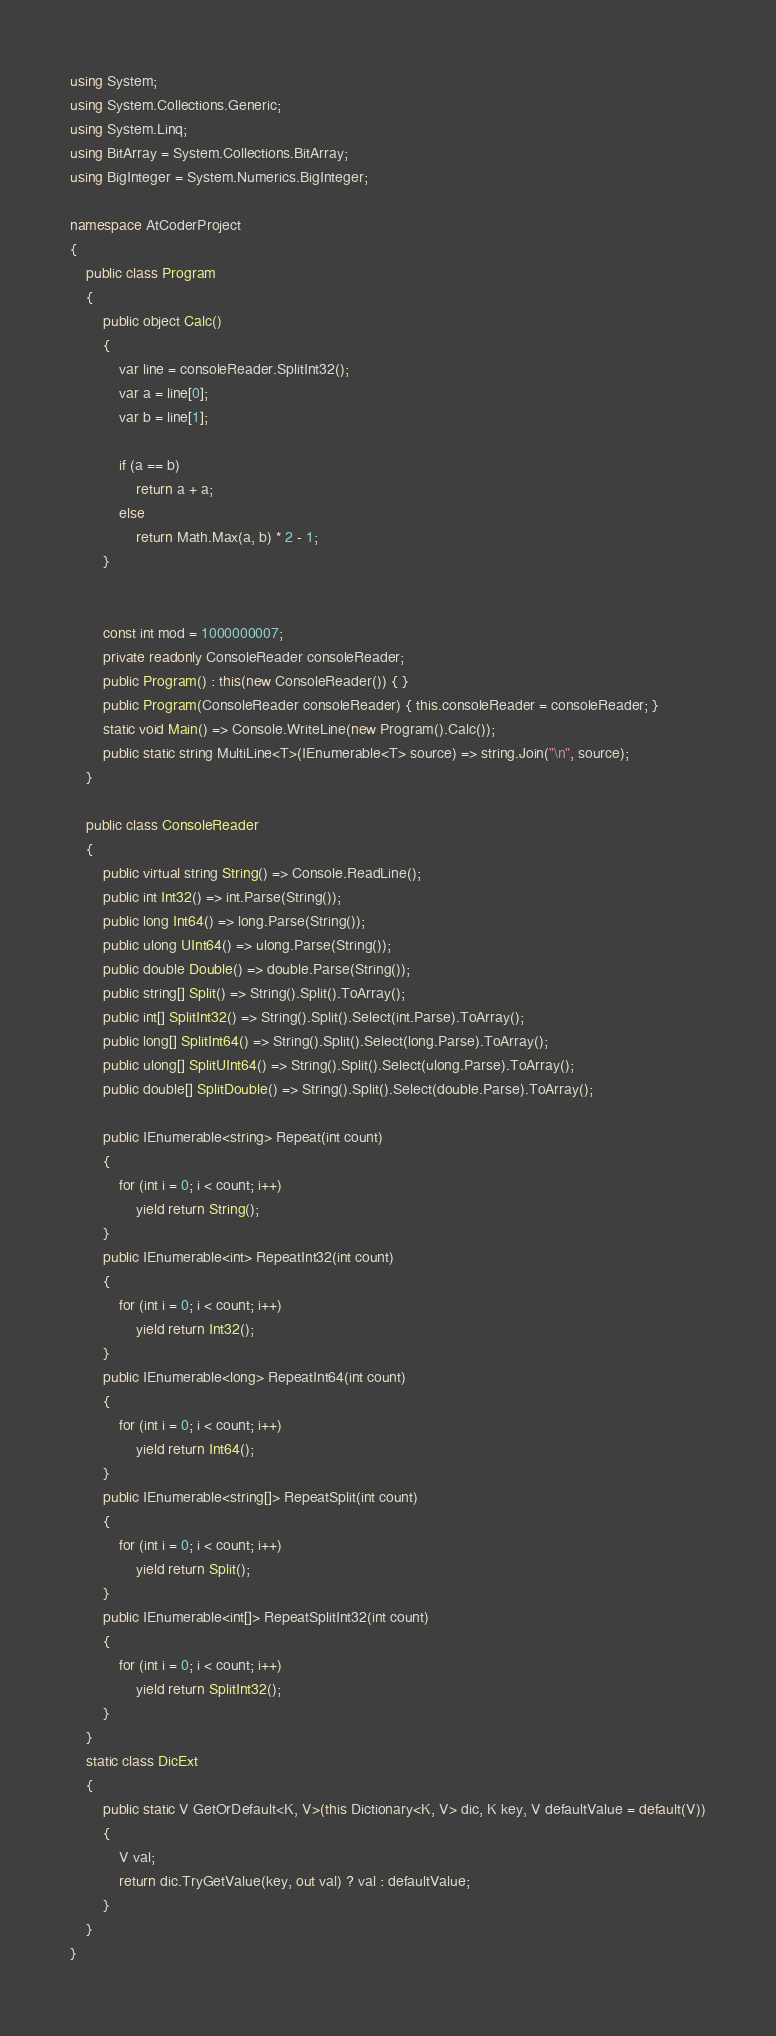<code> <loc_0><loc_0><loc_500><loc_500><_C#_>
using System;
using System.Collections.Generic;
using System.Linq;
using BitArray = System.Collections.BitArray;
using BigInteger = System.Numerics.BigInteger;

namespace AtCoderProject
{
    public class Program
    {
        public object Calc()
        {
            var line = consoleReader.SplitInt32();
            var a = line[0];
            var b = line[1];

            if (a == b)
                return a + a;
            else
                return Math.Max(a, b) * 2 - 1;
        }


        const int mod = 1000000007;
        private readonly ConsoleReader consoleReader;
        public Program() : this(new ConsoleReader()) { }
        public Program(ConsoleReader consoleReader) { this.consoleReader = consoleReader; }
        static void Main() => Console.WriteLine(new Program().Calc());
        public static string MultiLine<T>(IEnumerable<T> source) => string.Join("\n", source);
    }

    public class ConsoleReader
    {
        public virtual string String() => Console.ReadLine();
        public int Int32() => int.Parse(String());
        public long Int64() => long.Parse(String());
        public ulong UInt64() => ulong.Parse(String());
        public double Double() => double.Parse(String());
        public string[] Split() => String().Split().ToArray();
        public int[] SplitInt32() => String().Split().Select(int.Parse).ToArray();
        public long[] SplitInt64() => String().Split().Select(long.Parse).ToArray();
        public ulong[] SplitUInt64() => String().Split().Select(ulong.Parse).ToArray();
        public double[] SplitDouble() => String().Split().Select(double.Parse).ToArray();

        public IEnumerable<string> Repeat(int count)
        {
            for (int i = 0; i < count; i++)
                yield return String();
        }
        public IEnumerable<int> RepeatInt32(int count)
        {
            for (int i = 0; i < count; i++)
                yield return Int32();
        }
        public IEnumerable<long> RepeatInt64(int count)
        {
            for (int i = 0; i < count; i++)
                yield return Int64();
        }
        public IEnumerable<string[]> RepeatSplit(int count)
        {
            for (int i = 0; i < count; i++)
                yield return Split();
        }
        public IEnumerable<int[]> RepeatSplitInt32(int count)
        {
            for (int i = 0; i < count; i++)
                yield return SplitInt32();
        }
    }
    static class DicExt
    {
        public static V GetOrDefault<K, V>(this Dictionary<K, V> dic, K key, V defaultValue = default(V))
        {
            V val;
            return dic.TryGetValue(key, out val) ? val : defaultValue;
        }
    }
}
</code> 